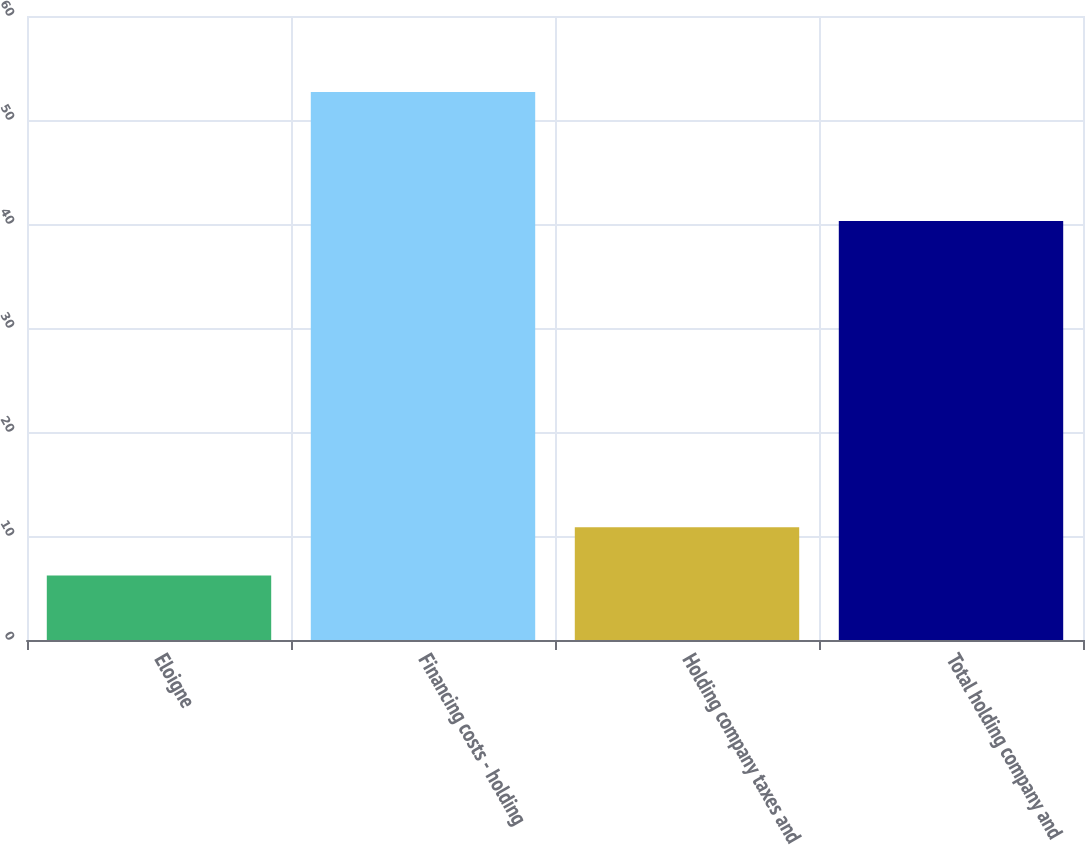Convert chart to OTSL. <chart><loc_0><loc_0><loc_500><loc_500><bar_chart><fcel>Eloigne<fcel>Financing costs - holding<fcel>Holding company taxes and<fcel>Total holding company and<nl><fcel>6.2<fcel>52.7<fcel>10.85<fcel>40.3<nl></chart> 